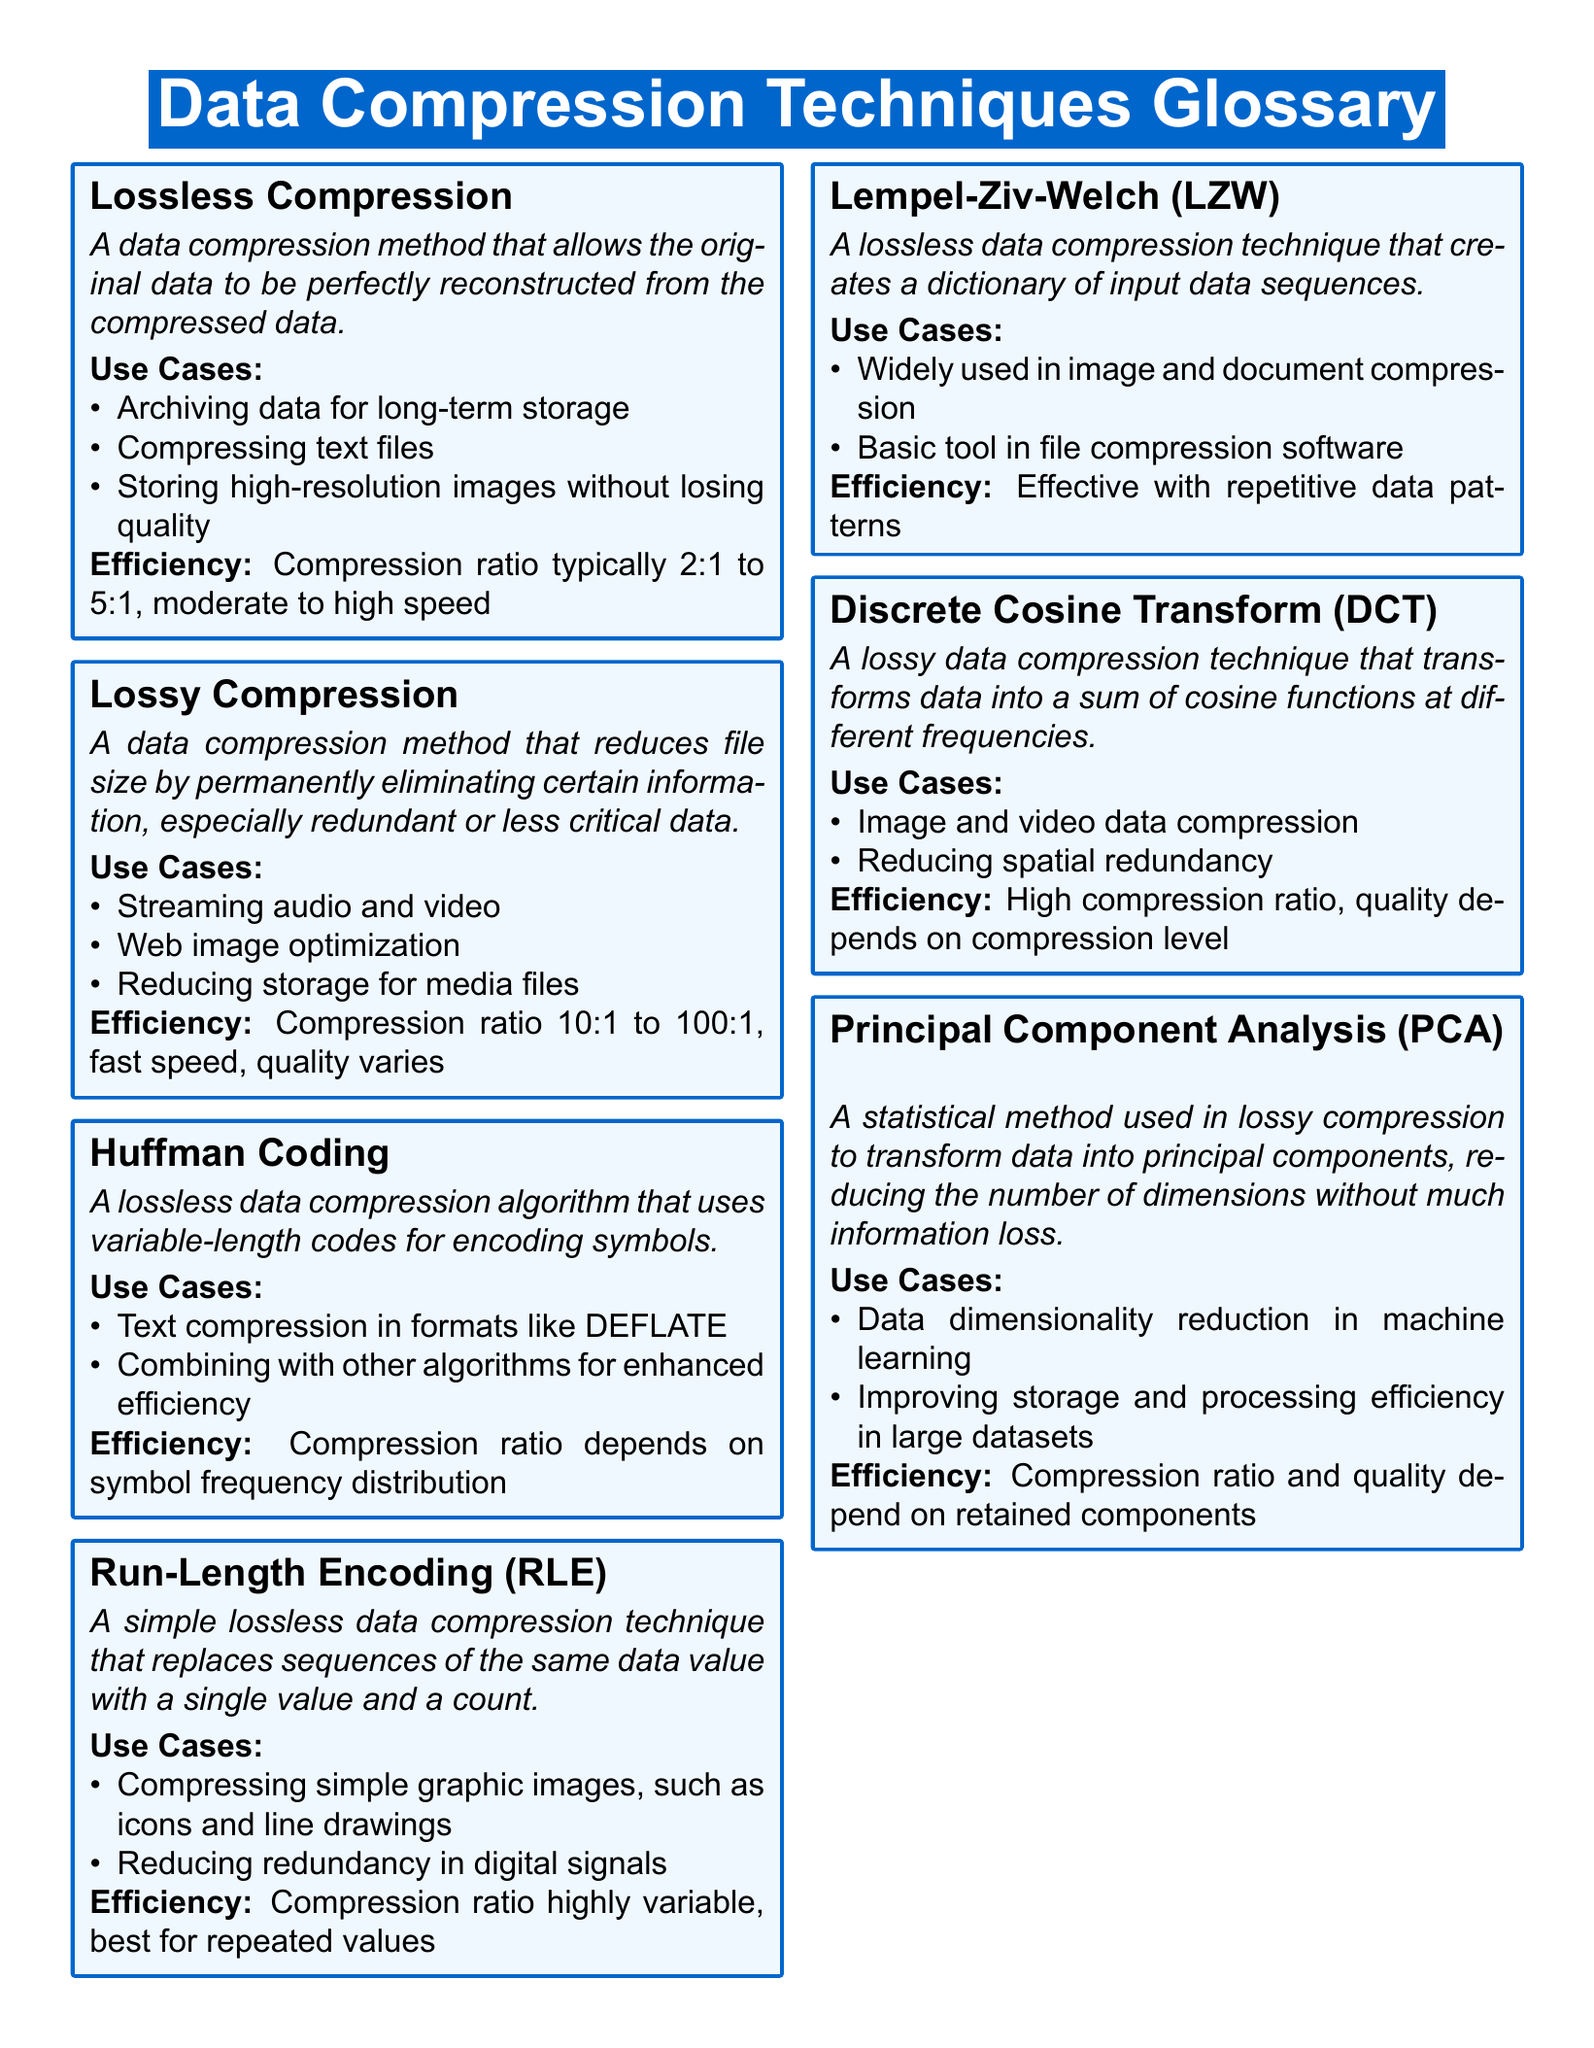What is lossless compression? Lossless compression is defined as a data compression method that allows the original data to be perfectly reconstructed from the compressed data.
Answer: A data compression method that allows the original data to be perfectly reconstructed from the compressed data What is the typical compression ratio for lossless compression? The document states that the compression ratio for lossless compression typically ranges from 2:1 to 5:1.
Answer: 2:1 to 5:1 What is a use case for lossy compression? The document lists several use cases for lossy compression, one being streaming audio and video.
Answer: Streaming audio and video What does Huffman Coding implement? Huffman Coding implements a lossless data compression algorithm that uses variable-length codes for encoding symbols.
Answer: A lossless data compression algorithm that uses variable-length codes for encoding symbols What compression technique is commonly used in image compression? The glossary mentions the Lempel-Ziv-Welch (LZW) technique as being widely used in image compression.
Answer: Lempel-Ziv-Welch (LZW) What is the efficiency of lossy compression? The document specifies that the compression ratio for lossy compression can range from 10:1 to 100:1, but the quality varies.
Answer: 10:1 to 100:1 What does Discrete Cosine Transform primarily target? The Discrete Cosine Transform is primarily used for image and video data compression as mentioned in the document.
Answer: Image and video data compression What is the main focus of Principal Component Analysis? Principal Component Analysis focuses on data dimensionality reduction in machine learning according to the document.
Answer: Data dimensionality reduction in machine learning 